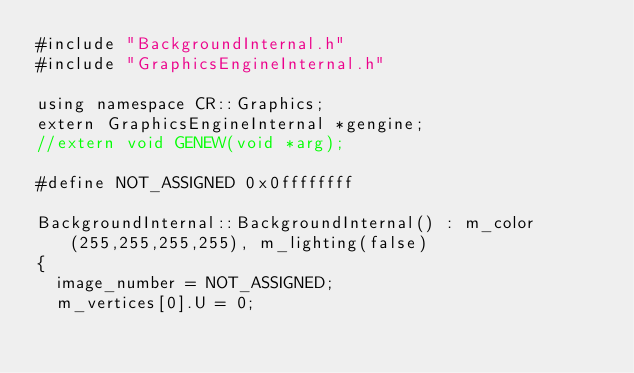<code> <loc_0><loc_0><loc_500><loc_500><_ObjectiveC_>#include "BackgroundInternal.h"
#include "GraphicsEngineInternal.h"

using namespace CR::Graphics;
extern GraphicsEngineInternal *gengine;
//extern void GENEW(void *arg);

#define NOT_ASSIGNED 0x0ffffffff

BackgroundInternal::BackgroundInternal() : m_color(255,255,255,255), m_lighting(false)
{
	image_number = NOT_ASSIGNED;
	m_vertices[0].U = 0;</code> 